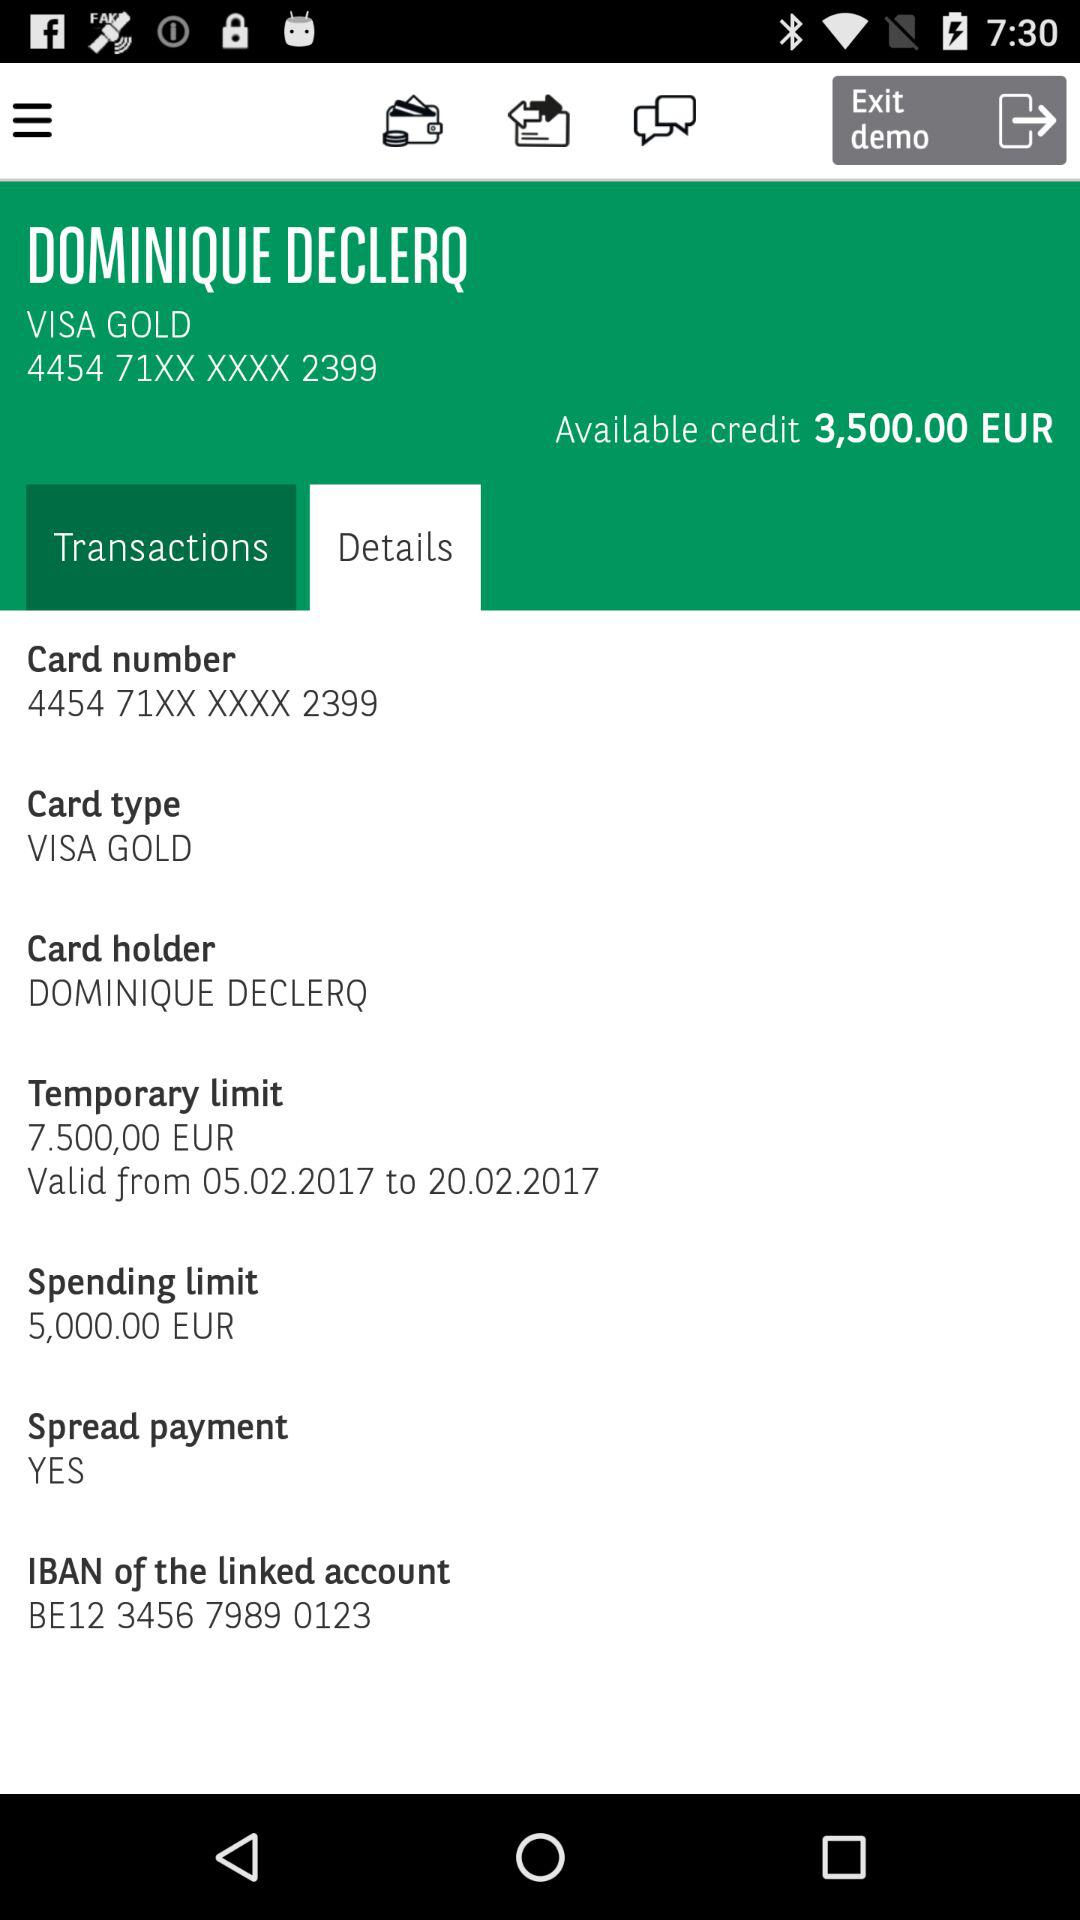What is the spending limit of the card? The spending limit of the card is 5,000 euros. 